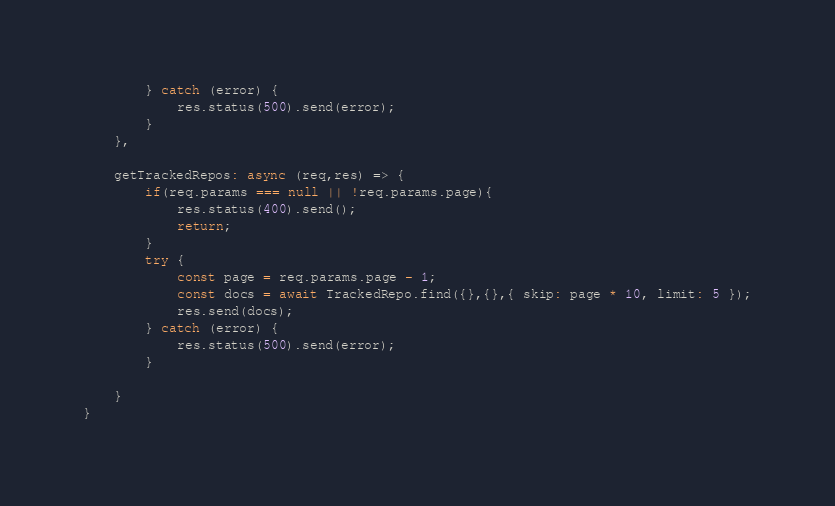<code> <loc_0><loc_0><loc_500><loc_500><_JavaScript_>        } catch (error) {
            res.status(500).send(error);
        }
    },

    getTrackedRepos: async (req,res) => {
        if(req.params === null || !req.params.page){
            res.status(400).send();
            return;
        }
        try {
            const page = req.params.page - 1;
            const docs = await TrackedRepo.find({},{},{ skip: page * 10, limit: 5 });
            res.send(docs);
        } catch (error) {
            res.status(500).send(error);
        }

    }
}</code> 